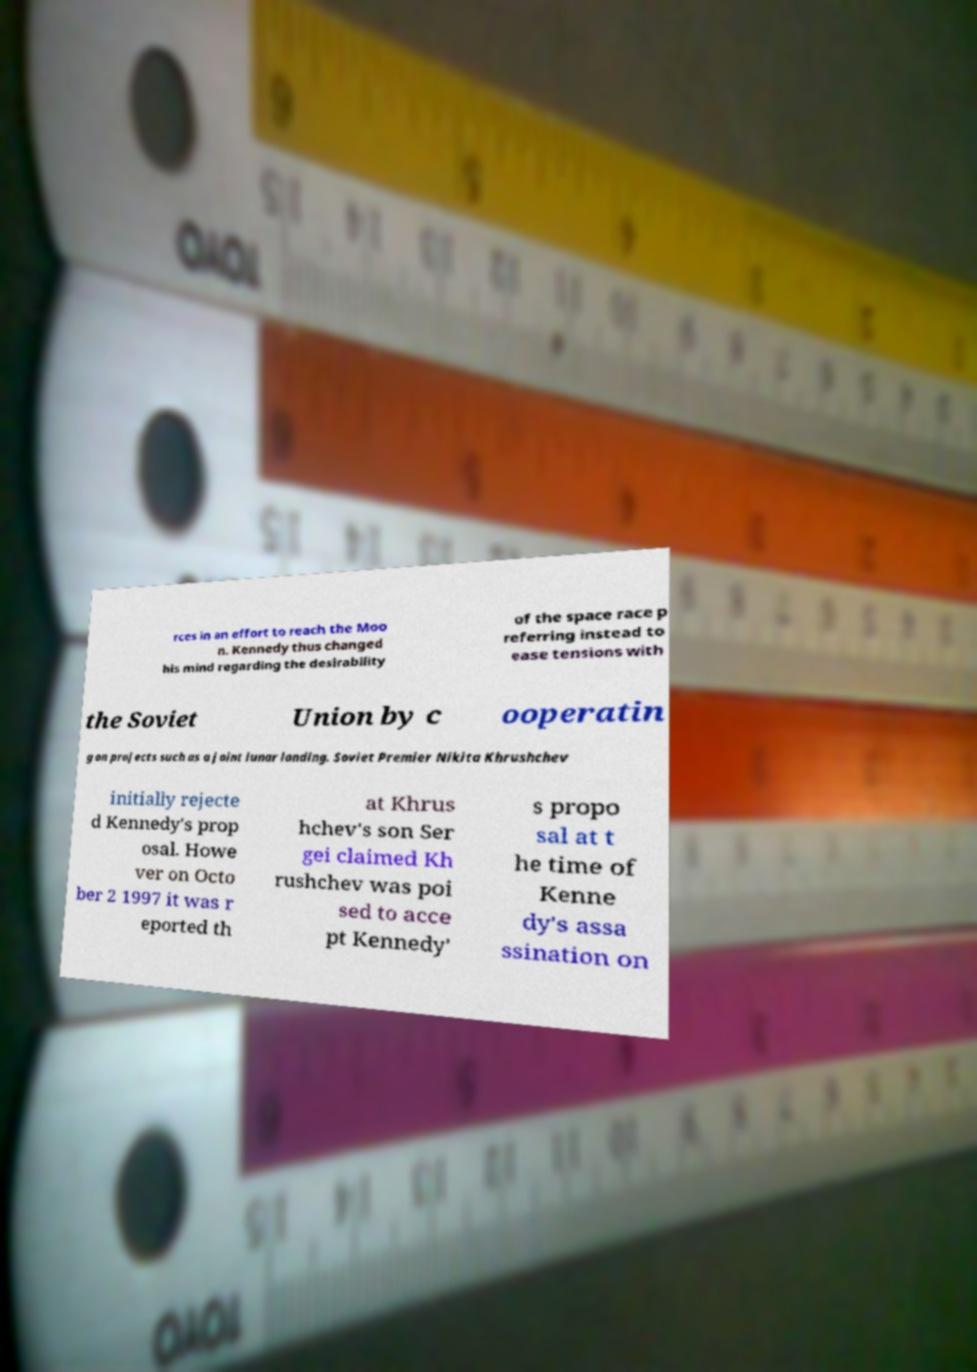Please read and relay the text visible in this image. What does it say? rces in an effort to reach the Moo n. Kennedy thus changed his mind regarding the desirability of the space race p referring instead to ease tensions with the Soviet Union by c ooperatin g on projects such as a joint lunar landing. Soviet Premier Nikita Khrushchev initially rejecte d Kennedy's prop osal. Howe ver on Octo ber 2 1997 it was r eported th at Khrus hchev's son Ser gei claimed Kh rushchev was poi sed to acce pt Kennedy' s propo sal at t he time of Kenne dy's assa ssination on 